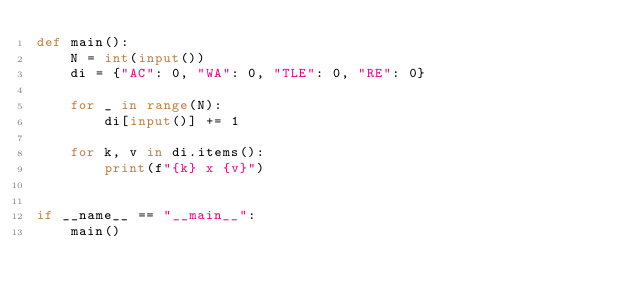Convert code to text. <code><loc_0><loc_0><loc_500><loc_500><_Python_>def main():
    N = int(input())
    di = {"AC": 0, "WA": 0, "TLE": 0, "RE": 0}

    for _ in range(N):
        di[input()] += 1

    for k, v in di.items():
        print(f"{k} x {v}")


if __name__ == "__main__":
    main()
</code> 